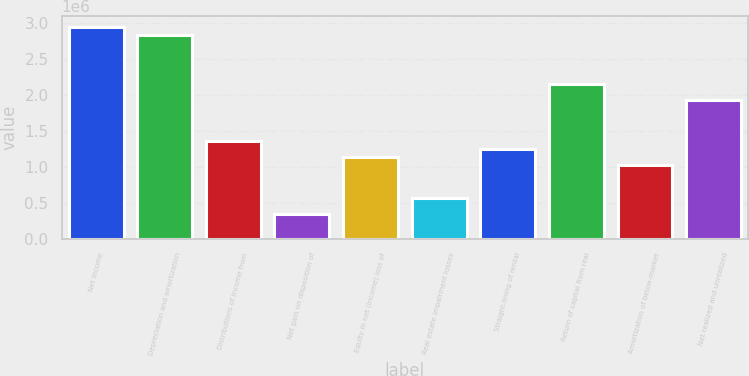Convert chart. <chart><loc_0><loc_0><loc_500><loc_500><bar_chart><fcel>Net income<fcel>Depreciation and amortization<fcel>Distributions of income from<fcel>Net gain on disposition of<fcel>Equity in net (income) loss of<fcel>Real estate impairment losses<fcel>Straight-lining of rental<fcel>Return of capital from real<fcel>Amortization of below-market<fcel>Net realized and unrealized<nl><fcel>2.94681e+06<fcel>2.83359e+06<fcel>1.36175e+06<fcel>342780<fcel>1.13531e+06<fcel>569218<fcel>1.24853e+06<fcel>2.15428e+06<fcel>1.02209e+06<fcel>1.92784e+06<nl></chart> 